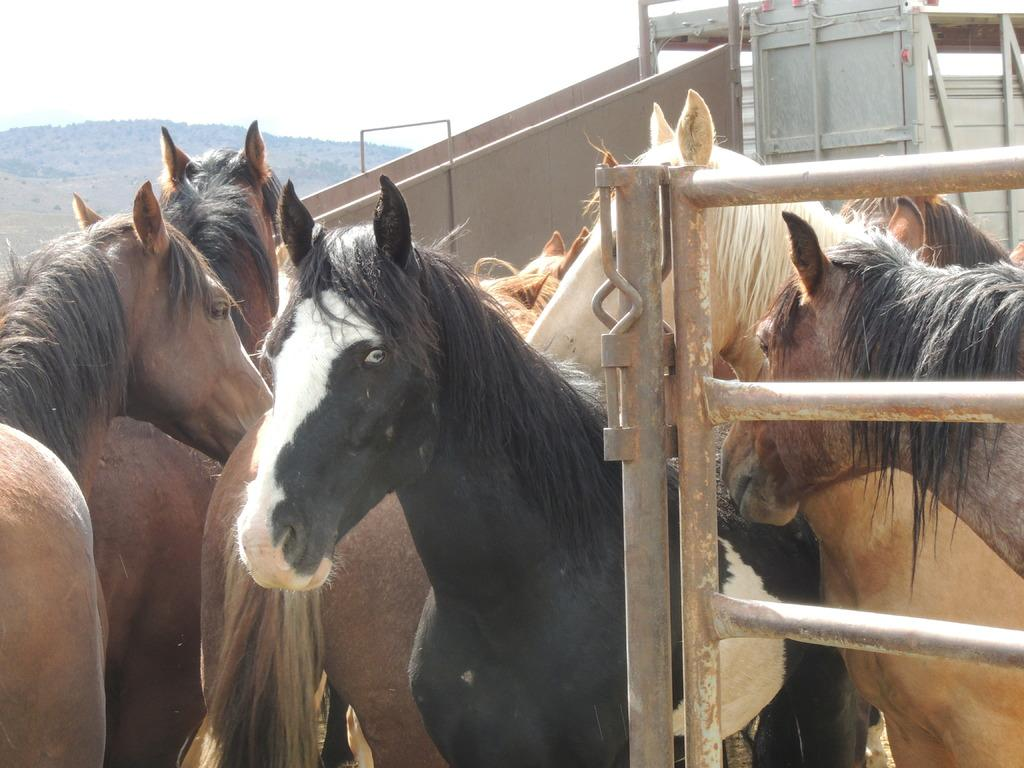What animals are present in the image? There are many horses in the image. What part of the natural environment is visible in the image? The sky is visible at the top of the image. What type of cracker is being used to express hate towards the moon in the image? There is no cracker, moon, or expression of hate present in the image. 